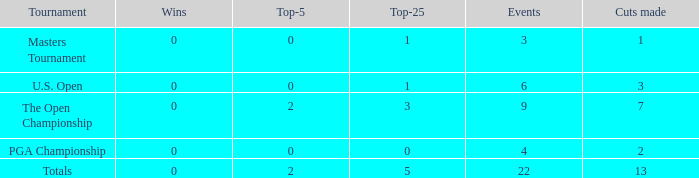Help me parse the entirety of this table. {'header': ['Tournament', 'Wins', 'Top-5', 'Top-25', 'Events', 'Cuts made'], 'rows': [['Masters Tournament', '0', '0', '1', '3', '1'], ['U.S. Open', '0', '0', '1', '6', '3'], ['The Open Championship', '0', '2', '3', '9', '7'], ['PGA Championship', '0', '0', '0', '4', '2'], ['Totals', '0', '2', '5', '22', '13']]} In events with fewer than 4 entries and at least 1 win, what is the typical number of cuts made? None. 